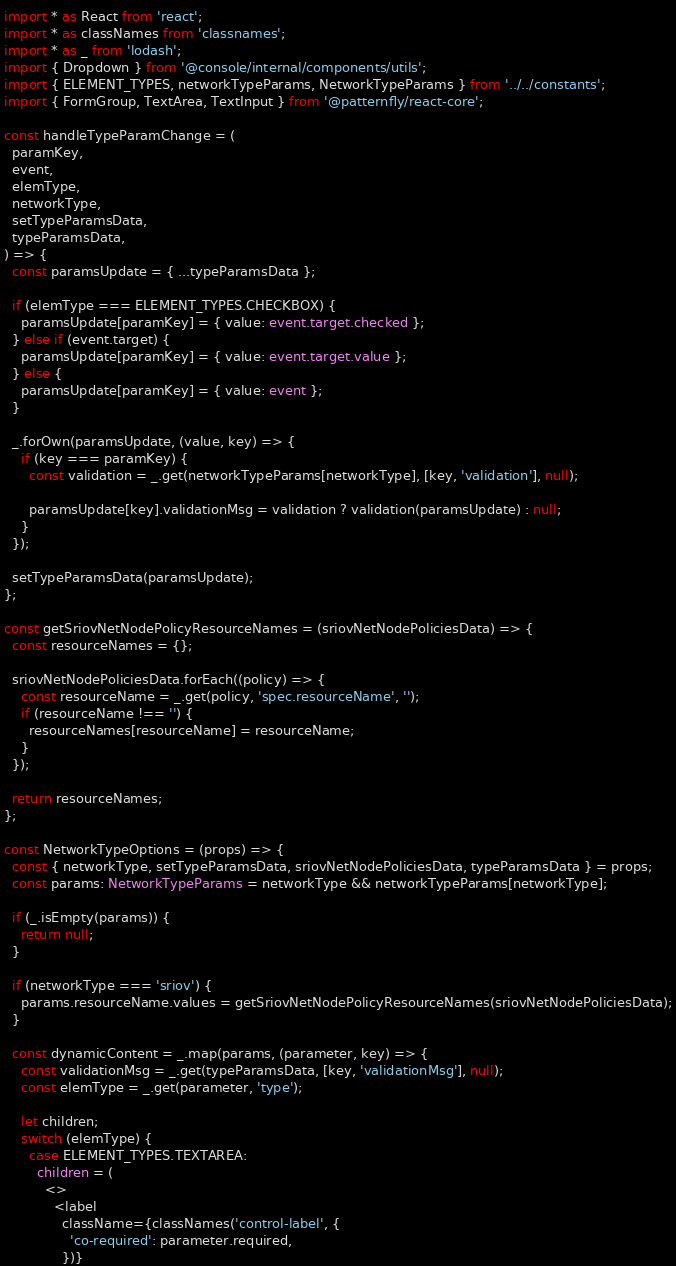<code> <loc_0><loc_0><loc_500><loc_500><_TypeScript_>import * as React from 'react';
import * as classNames from 'classnames';
import * as _ from 'lodash';
import { Dropdown } from '@console/internal/components/utils';
import { ELEMENT_TYPES, networkTypeParams, NetworkTypeParams } from '../../constants';
import { FormGroup, TextArea, TextInput } from '@patternfly/react-core';

const handleTypeParamChange = (
  paramKey,
  event,
  elemType,
  networkType,
  setTypeParamsData,
  typeParamsData,
) => {
  const paramsUpdate = { ...typeParamsData };

  if (elemType === ELEMENT_TYPES.CHECKBOX) {
    paramsUpdate[paramKey] = { value: event.target.checked };
  } else if (event.target) {
    paramsUpdate[paramKey] = { value: event.target.value };
  } else {
    paramsUpdate[paramKey] = { value: event };
  }

  _.forOwn(paramsUpdate, (value, key) => {
    if (key === paramKey) {
      const validation = _.get(networkTypeParams[networkType], [key, 'validation'], null);

      paramsUpdate[key].validationMsg = validation ? validation(paramsUpdate) : null;
    }
  });

  setTypeParamsData(paramsUpdate);
};

const getSriovNetNodePolicyResourceNames = (sriovNetNodePoliciesData) => {
  const resourceNames = {};

  sriovNetNodePoliciesData.forEach((policy) => {
    const resourceName = _.get(policy, 'spec.resourceName', '');
    if (resourceName !== '') {
      resourceNames[resourceName] = resourceName;
    }
  });

  return resourceNames;
};

const NetworkTypeOptions = (props) => {
  const { networkType, setTypeParamsData, sriovNetNodePoliciesData, typeParamsData } = props;
  const params: NetworkTypeParams = networkType && networkTypeParams[networkType];

  if (_.isEmpty(params)) {
    return null;
  }

  if (networkType === 'sriov') {
    params.resourceName.values = getSriovNetNodePolicyResourceNames(sriovNetNodePoliciesData);
  }

  const dynamicContent = _.map(params, (parameter, key) => {
    const validationMsg = _.get(typeParamsData, [key, 'validationMsg'], null);
    const elemType = _.get(parameter, 'type');

    let children;
    switch (elemType) {
      case ELEMENT_TYPES.TEXTAREA:
        children = (
          <>
            <label
              className={classNames('control-label', {
                'co-required': parameter.required,
              })}</code> 